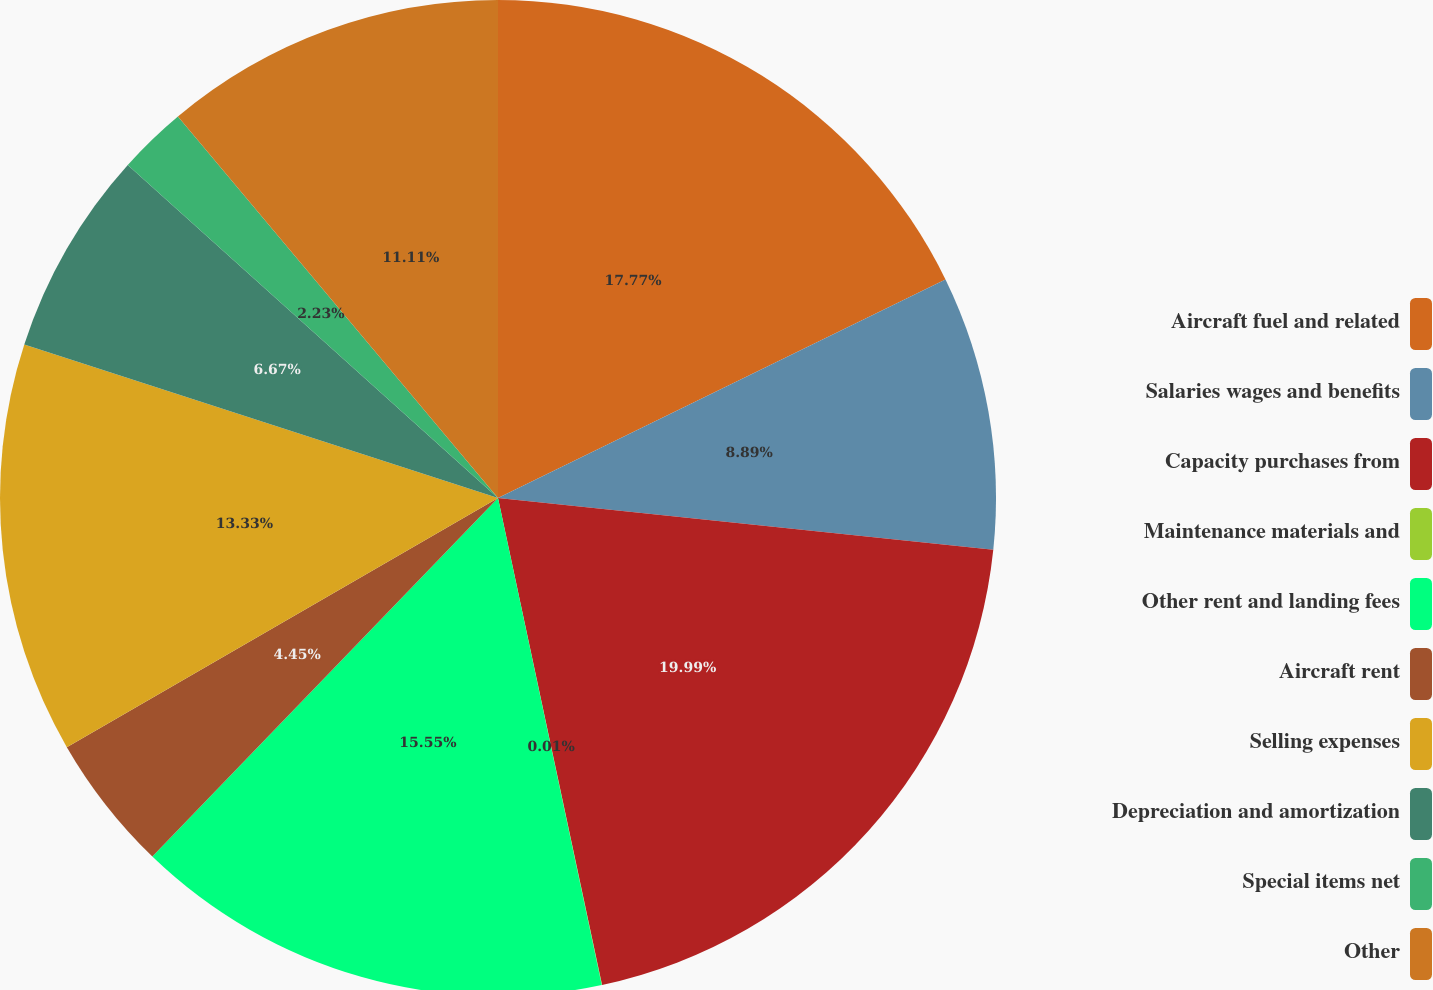<chart> <loc_0><loc_0><loc_500><loc_500><pie_chart><fcel>Aircraft fuel and related<fcel>Salaries wages and benefits<fcel>Capacity purchases from<fcel>Maintenance materials and<fcel>Other rent and landing fees<fcel>Aircraft rent<fcel>Selling expenses<fcel>Depreciation and amortization<fcel>Special items net<fcel>Other<nl><fcel>17.77%<fcel>8.89%<fcel>19.99%<fcel>0.01%<fcel>15.55%<fcel>4.45%<fcel>13.33%<fcel>6.67%<fcel>2.23%<fcel>11.11%<nl></chart> 